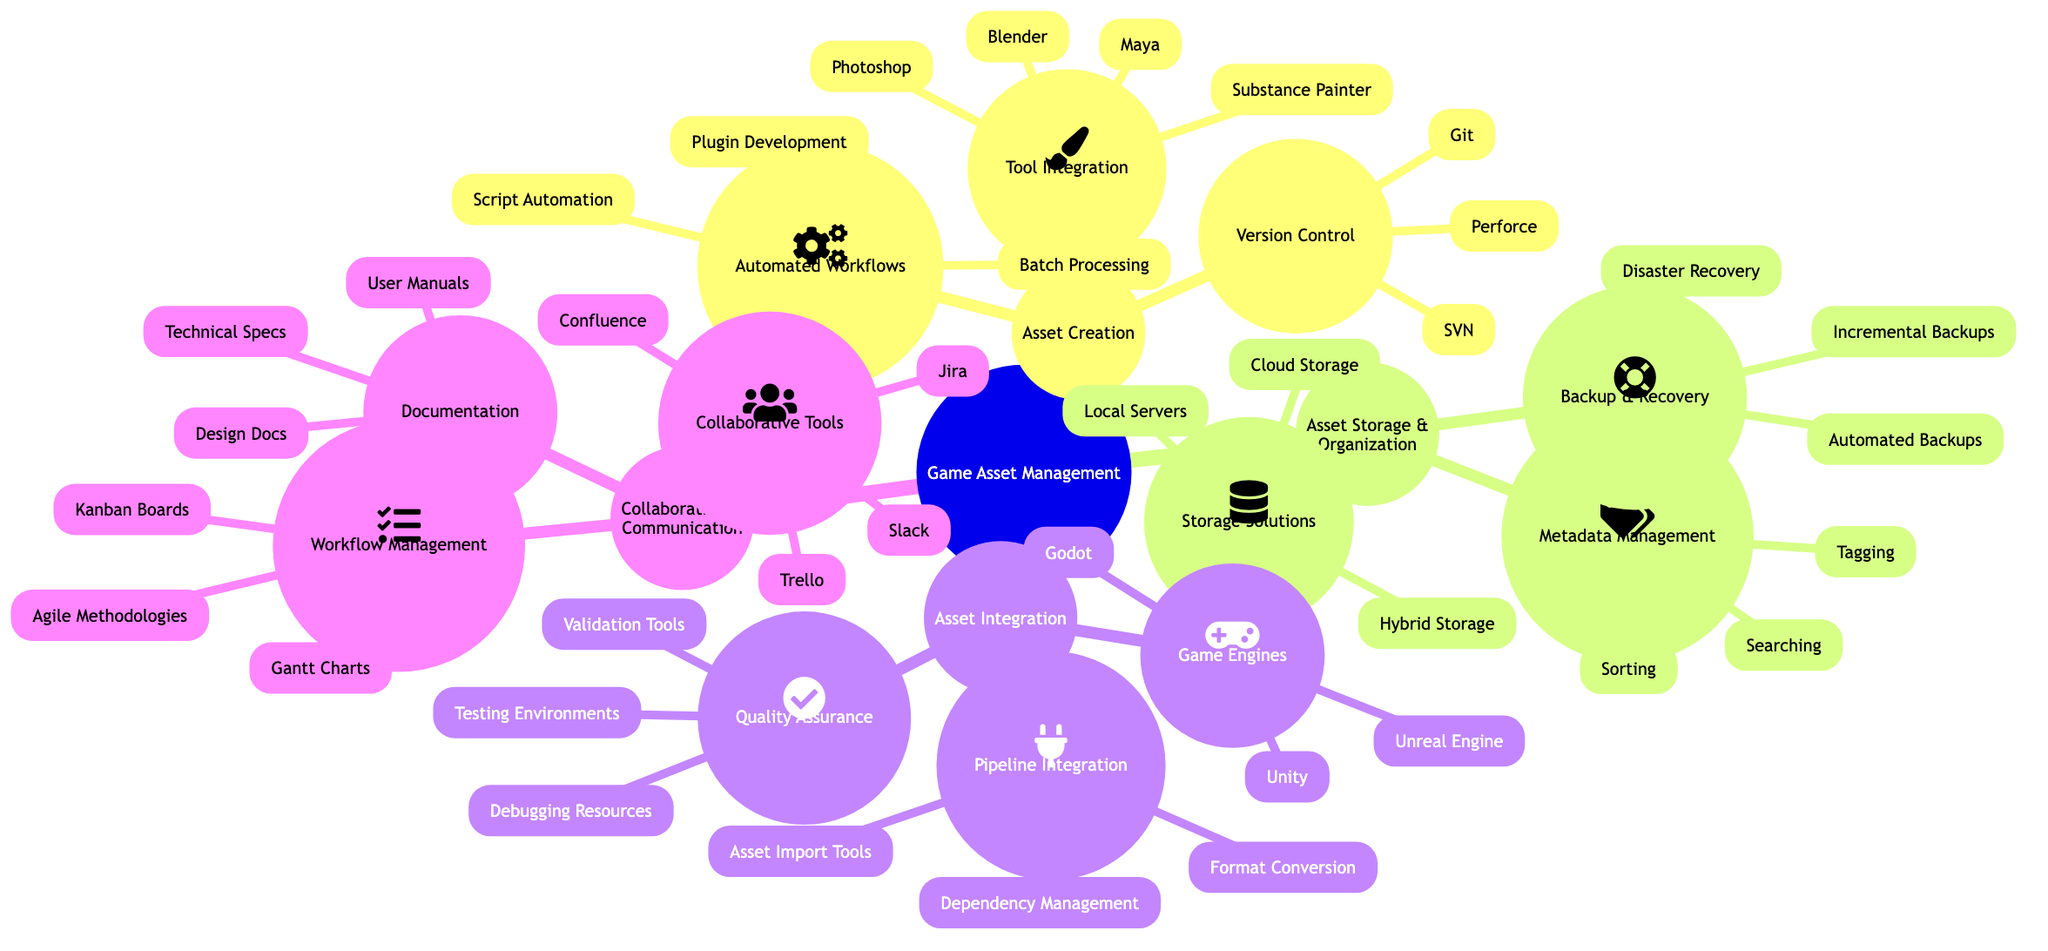What are the main subnodes under Game Asset Management? The main subnodes under Game Asset Management are Asset Creation, Asset Storage & Organization, Asset Integration, and Collaboration & Communication. This is derived from the first level of nodes branching off the main node.
Answer: Asset Creation, Asset Storage & Organization, Asset Integration, Collaboration & Communication How many elements are listed under the Tool Integration subnode? Under the Tool Integration subnode, there are four listed elements: Maya, Blender, Photoshop, and Substance Painter. This can be counted directly from the elements' list under that specific subnode.
Answer: 4 What is a common tool for Backup & Recovery? From the Backup & Recovery subnode, Automated Backups is one of the tools listed. This is referenced as one of the components under the relevant subnode.
Answer: Automated Backups How many game engines are mentioned in the Game Integration subnode? The Game Engines subnode includes three tools: Unity, Unreal Engine, and Godot. This can be counted directly from the list provided under that subnode.
Answer: 3 What is one element of Metadata Management? Tagging is one of the elements listed under Metadata Management. This is identified in the list provided under that specific subnode.
Answer: Tagging Which subnode includes Gantt Charts? Gantt Charts are found under the Workflow Management subnode. This is identified as a component beneath the specific subnode related to workflow.
Answer: Workflow Management What type of methodologies is included in the Workflow Management subnode? Agile Methodologies is included in the subnode for Workflow Management. This is confirmed by reviewing the elements listed under that specific subnode.
Answer: Agile Methodologies Which node would you look under for Plugin Development? Plugin Development can be found under the Automated Workflows subnode, as it is a part of the elements listed in that section.
Answer: Automated Workflows Which tools are listed in the Collaborative Tools subnode? The Collaborative Tools subnode includes Slack, Trello, Jira, and Confluence. This can be confirmed by checking the list available under that specific subnode.
Answer: Slack, Trello, Jira, Confluence 